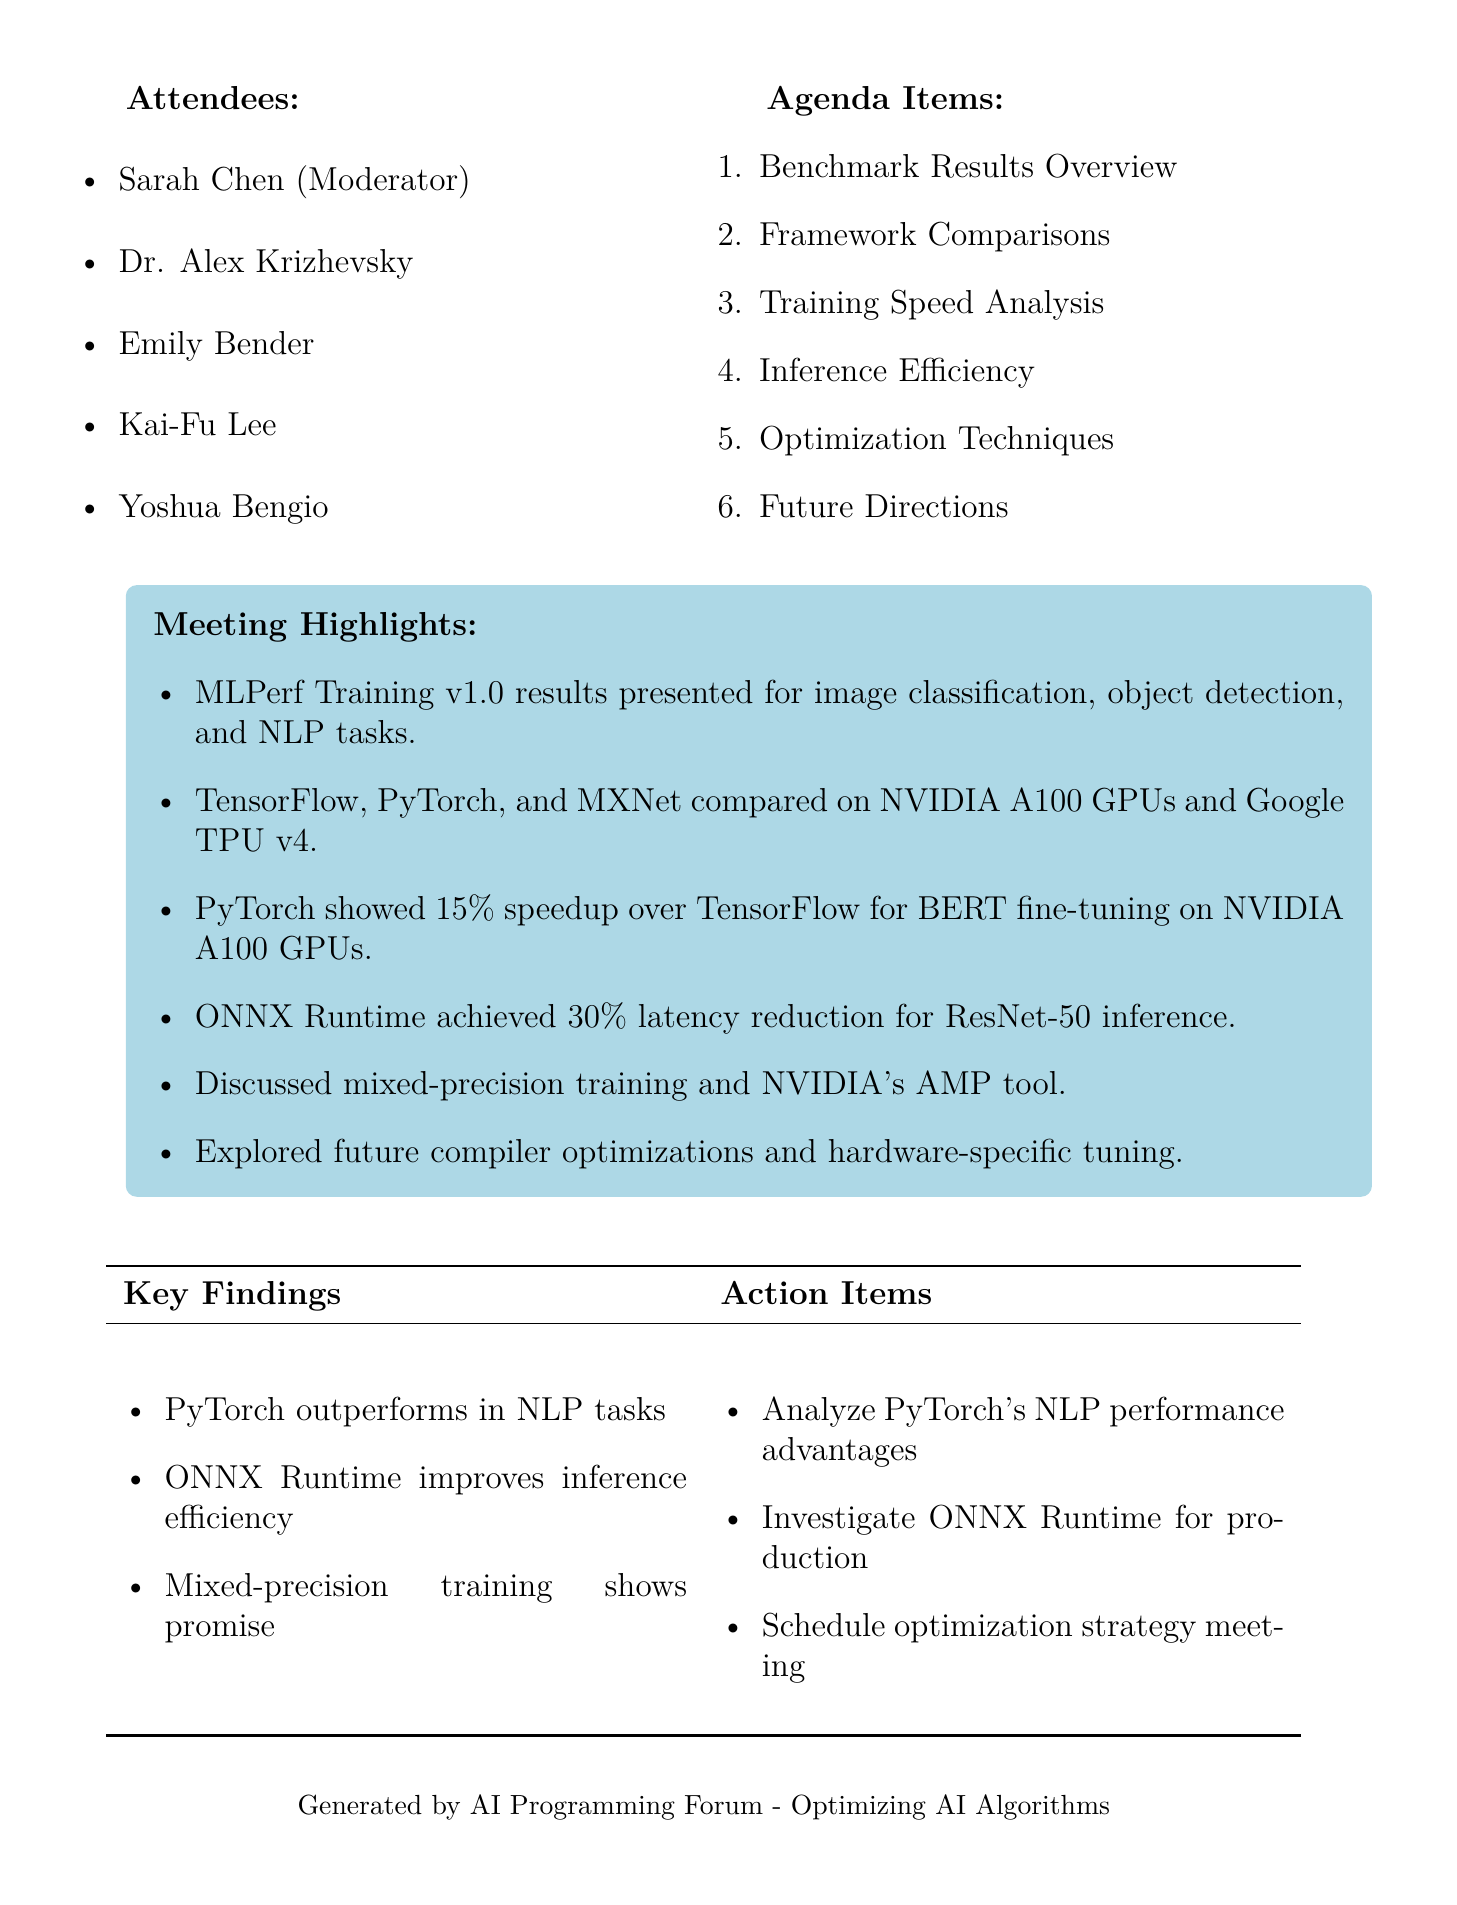What is the date of the meeting? The date of the meeting is explicitly stated in the document under the title section.
Answer: 2023-05-15 Who was the moderator of the meeting? The moderator's name is listed in the attendees section, which provides details of meeting participants.
Answer: Sarah Chen What is the main focus of the benchmark results presented? The content under "Benchmark Results Overview" reveals that the focus was on specific deep learning tasks, which is repeatedly emphasized in the document.
Answer: image classification, object detection, and natural language processing tasks Which framework showed a speedup in BERT fine-tuning? The "Training Speed Analysis" section mentions the comparative performance of frameworks in BERT fine-tuning, indicating which performed better.
Answer: PyTorch What percentage of latency reduction does ONNX Runtime achieve for ResNet-50 inference? The "Inference Efficiency" section specifies the exact reduction in latency provided by ONNX Runtime.
Answer: 30% What optimization technique was discussed related to NVIDIA? The "Optimization Techniques" section highlights a specific tool related to NVIDIA that is focused on improving training efficiency.
Answer: Automatic Mixed Precision What was one of the action items decided in the meeting? The "Action Items" section lists specific follow-up tasks that participants agreed to focus on after the meeting.
Answer: Conduct in-depth analysis of PyTorch's performance advantages for NLP tasks What is the purpose of the follow-up meeting? The action items outline the objective of scheduling future discussions for enhancing overall strategies, underscoring the motivation behind it.
Answer: Discuss custom optimization strategies for our specific use cases 